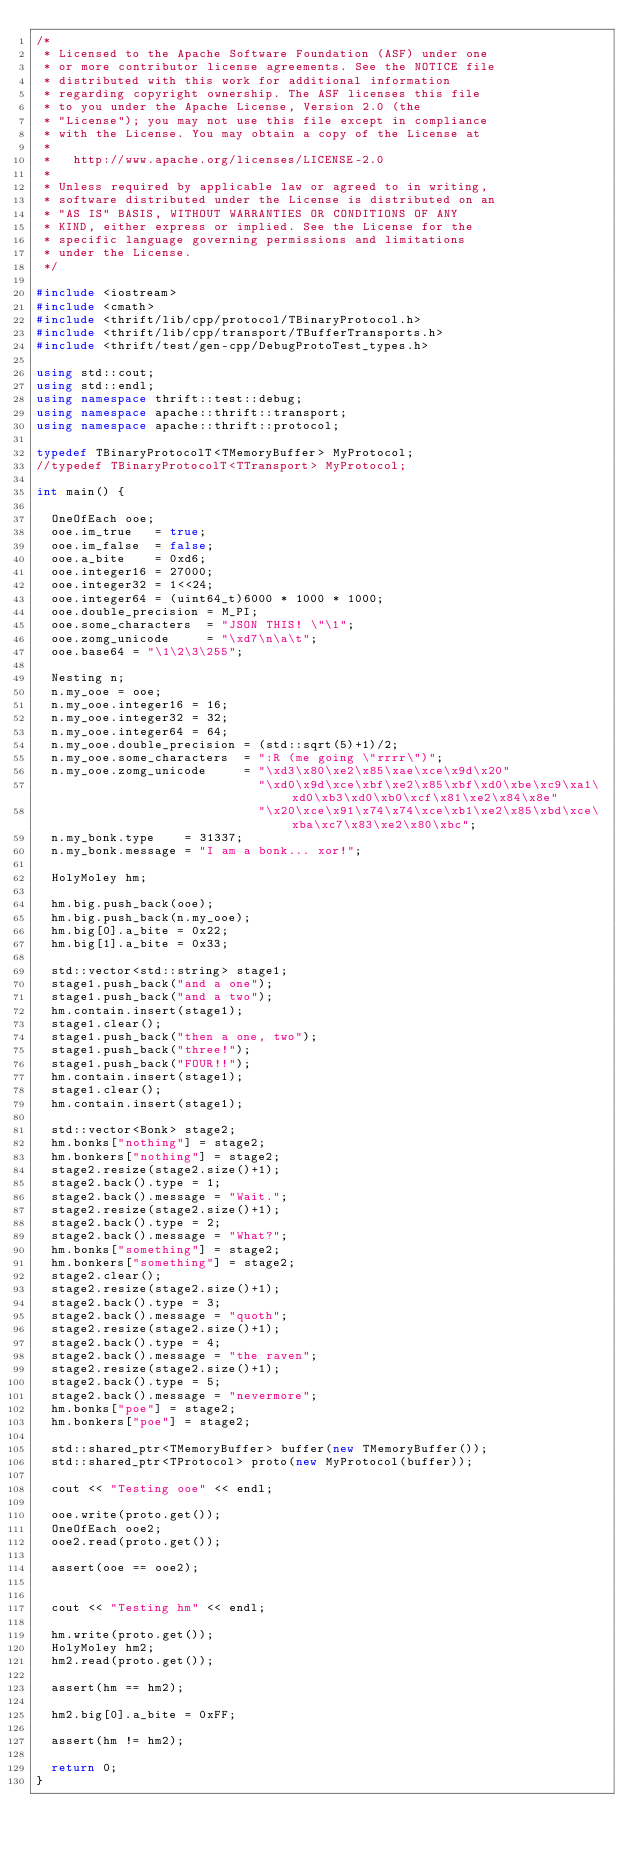<code> <loc_0><loc_0><loc_500><loc_500><_C++_>/*
 * Licensed to the Apache Software Foundation (ASF) under one
 * or more contributor license agreements. See the NOTICE file
 * distributed with this work for additional information
 * regarding copyright ownership. The ASF licenses this file
 * to you under the Apache License, Version 2.0 (the
 * "License"); you may not use this file except in compliance
 * with the License. You may obtain a copy of the License at
 *
 *   http://www.apache.org/licenses/LICENSE-2.0
 *
 * Unless required by applicable law or agreed to in writing,
 * software distributed under the License is distributed on an
 * "AS IS" BASIS, WITHOUT WARRANTIES OR CONDITIONS OF ANY
 * KIND, either express or implied. See the License for the
 * specific language governing permissions and limitations
 * under the License.
 */

#include <iostream>
#include <cmath>
#include <thrift/lib/cpp/protocol/TBinaryProtocol.h>
#include <thrift/lib/cpp/transport/TBufferTransports.h>
#include <thrift/test/gen-cpp/DebugProtoTest_types.h>

using std::cout;
using std::endl;
using namespace thrift::test::debug;
using namespace apache::thrift::transport;
using namespace apache::thrift::protocol;

typedef TBinaryProtocolT<TMemoryBuffer> MyProtocol;
//typedef TBinaryProtocolT<TTransport> MyProtocol;

int main() {

  OneOfEach ooe;
  ooe.im_true   = true;
  ooe.im_false  = false;
  ooe.a_bite    = 0xd6;
  ooe.integer16 = 27000;
  ooe.integer32 = 1<<24;
  ooe.integer64 = (uint64_t)6000 * 1000 * 1000;
  ooe.double_precision = M_PI;
  ooe.some_characters  = "JSON THIS! \"\1";
  ooe.zomg_unicode     = "\xd7\n\a\t";
  ooe.base64 = "\1\2\3\255";

  Nesting n;
  n.my_ooe = ooe;
  n.my_ooe.integer16 = 16;
  n.my_ooe.integer32 = 32;
  n.my_ooe.integer64 = 64;
  n.my_ooe.double_precision = (std::sqrt(5)+1)/2;
  n.my_ooe.some_characters  = ":R (me going \"rrrr\")";
  n.my_ooe.zomg_unicode     = "\xd3\x80\xe2\x85\xae\xce\x9d\x20"
                              "\xd0\x9d\xce\xbf\xe2\x85\xbf\xd0\xbe\xc9\xa1\xd0\xb3\xd0\xb0\xcf\x81\xe2\x84\x8e"
                              "\x20\xce\x91\x74\x74\xce\xb1\xe2\x85\xbd\xce\xba\xc7\x83\xe2\x80\xbc";
  n.my_bonk.type    = 31337;
  n.my_bonk.message = "I am a bonk... xor!";

  HolyMoley hm;

  hm.big.push_back(ooe);
  hm.big.push_back(n.my_ooe);
  hm.big[0].a_bite = 0x22;
  hm.big[1].a_bite = 0x33;

  std::vector<std::string> stage1;
  stage1.push_back("and a one");
  stage1.push_back("and a two");
  hm.contain.insert(stage1);
  stage1.clear();
  stage1.push_back("then a one, two");
  stage1.push_back("three!");
  stage1.push_back("FOUR!!");
  hm.contain.insert(stage1);
  stage1.clear();
  hm.contain.insert(stage1);

  std::vector<Bonk> stage2;
  hm.bonks["nothing"] = stage2;
  hm.bonkers["nothing"] = stage2;
  stage2.resize(stage2.size()+1);
  stage2.back().type = 1;
  stage2.back().message = "Wait.";
  stage2.resize(stage2.size()+1);
  stage2.back().type = 2;
  stage2.back().message = "What?";
  hm.bonks["something"] = stage2;
  hm.bonkers["something"] = stage2;
  stage2.clear();
  stage2.resize(stage2.size()+1);
  stage2.back().type = 3;
  stage2.back().message = "quoth";
  stage2.resize(stage2.size()+1);
  stage2.back().type = 4;
  stage2.back().message = "the raven";
  stage2.resize(stage2.size()+1);
  stage2.back().type = 5;
  stage2.back().message = "nevermore";
  hm.bonks["poe"] = stage2;
  hm.bonkers["poe"] = stage2;

  std::shared_ptr<TMemoryBuffer> buffer(new TMemoryBuffer());
  std::shared_ptr<TProtocol> proto(new MyProtocol(buffer));

  cout << "Testing ooe" << endl;

  ooe.write(proto.get());
  OneOfEach ooe2;
  ooe2.read(proto.get());

  assert(ooe == ooe2);


  cout << "Testing hm" << endl;

  hm.write(proto.get());
  HolyMoley hm2;
  hm2.read(proto.get());

  assert(hm == hm2);

  hm2.big[0].a_bite = 0xFF;

  assert(hm != hm2);

  return 0;
}
</code> 